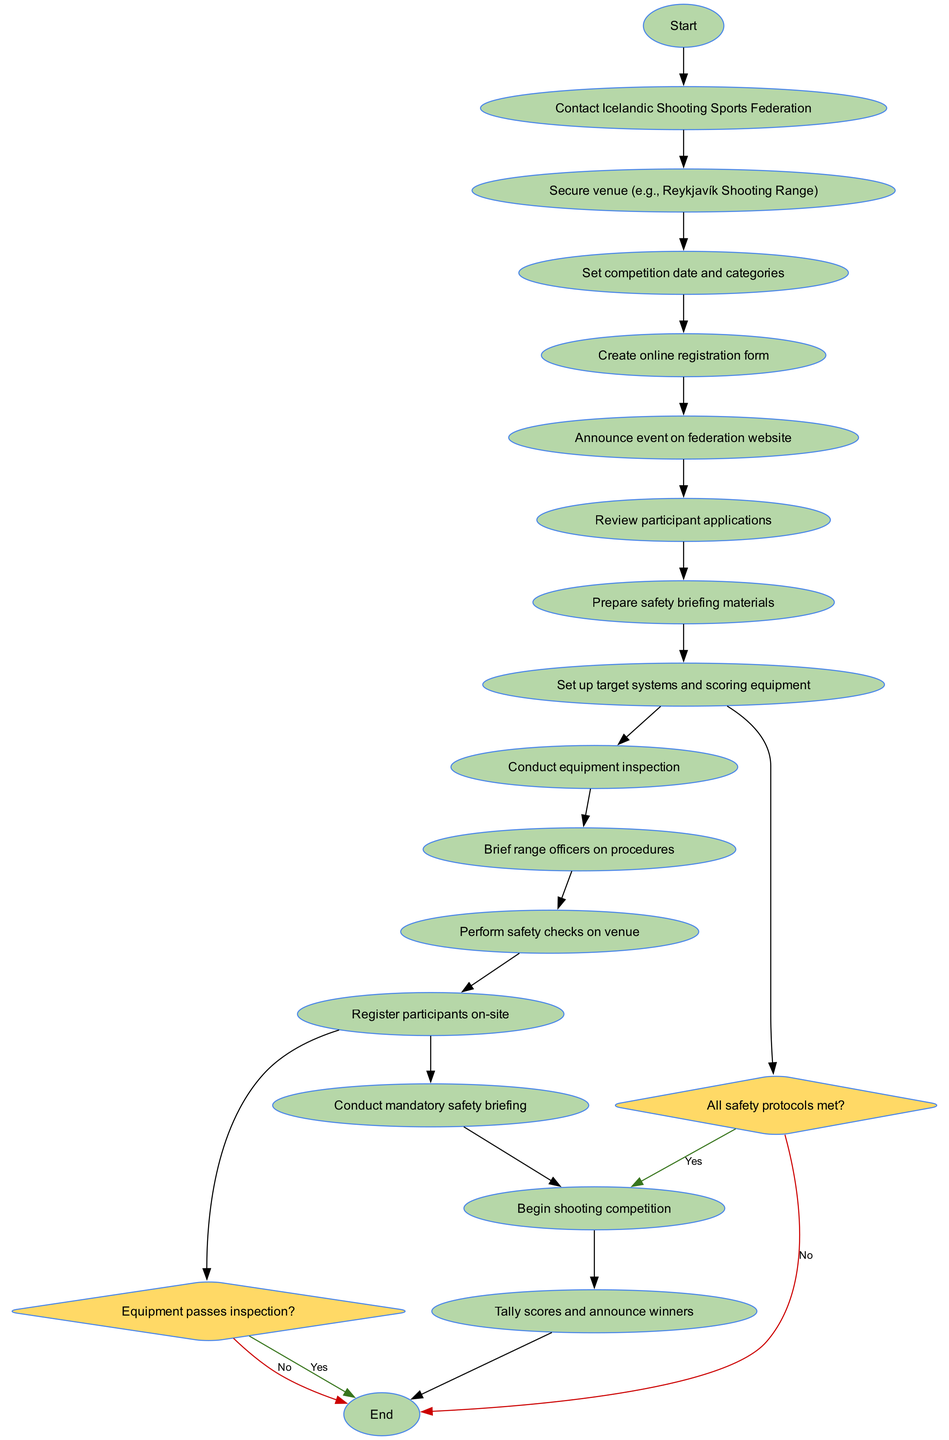What is the starting point of the competition planning process? The starting point is indicated by the first node in the diagram, labeled "Begin competition planning."
Answer: Begin competition planning How many activities are shown in the diagram? By counting the activities listed in the data, we see there are 14 activities in total.
Answer: 14 What is the last activity before concluding the competition? The last activity before the end node is "Tally scores and announce winners," as it is the final step before concluding.
Answer: Tally scores and announce winners What decision must be made after the equipment inspection activity? The decision made after equipment inspection is whether "Equipment passes inspection?" which determines the next step in the process.
Answer: Equipment passes inspection? Which activity comes after the registration of participants on-site? After registering participants on-site, the next activity is to "Conduct mandatory safety briefing."
Answer: Conduct mandatory safety briefing What happens if the safety protocols are not met? If safety protocols are not met, the flow indicates to "Address safety concerns," which shows a corrective action is required.
Answer: Address safety concerns What is the outcome if the equipment does not pass inspection? The flow diagram specifies that if the equipment does not pass inspection, the action is to "Deny participation."
Answer: Deny participation How many decision points are included in the diagram? There are 2 decision points in the diagram as identified: one after equipment inspection and one after safety checks.
Answer: 2 What is the transition from "Conduct equipment inspection"? The next step after "Conduct equipment inspection" is to reach a decision point about whether the equipment passes inspection or not.
Answer: Decision point about equipment inspection 